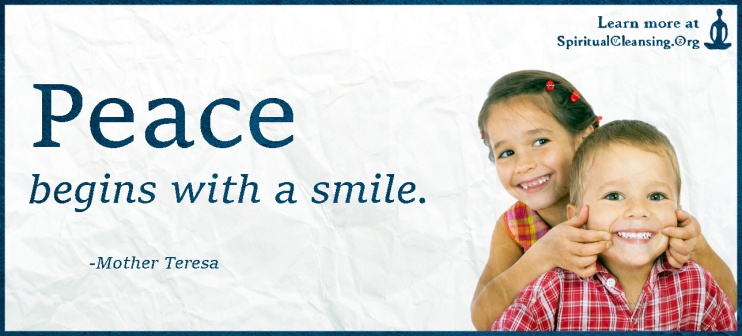Can you elaborate on the elements of the picture provided? Certainly! The image serves as a banner advertisement for the website SpiritualCleansing.org. The background is primarily light blue, overlaid with a subtle white texture, creating a serene and calming effect. Dominating the left side is a motivational quote by Mother Teresa, written in a dark blue, serif font: 'Peace begins with a smile.' Her name is credited just below the quote in a smaller font. To the right of the quote, there is a captivating photograph of two young children—a girl and a boy—engaging in playful antics. The girl on the left side of the photo is dressed in a pink shirt and is joyfully smiling, while the boy, clad in a blue shirt, mirrors her excitement with an equally infectious smile. Their joyous expressions vividly bring to life the essence of the quote. Additionally, the website's name, SpiritualCleansing.org, appears discreetly in the top right corner of the banner, encouraging viewers to visit the site for more inspiring content. The overall presentation cleverly ties together the children's joy with the message of peace conveyed by Mother Teresa's words. 